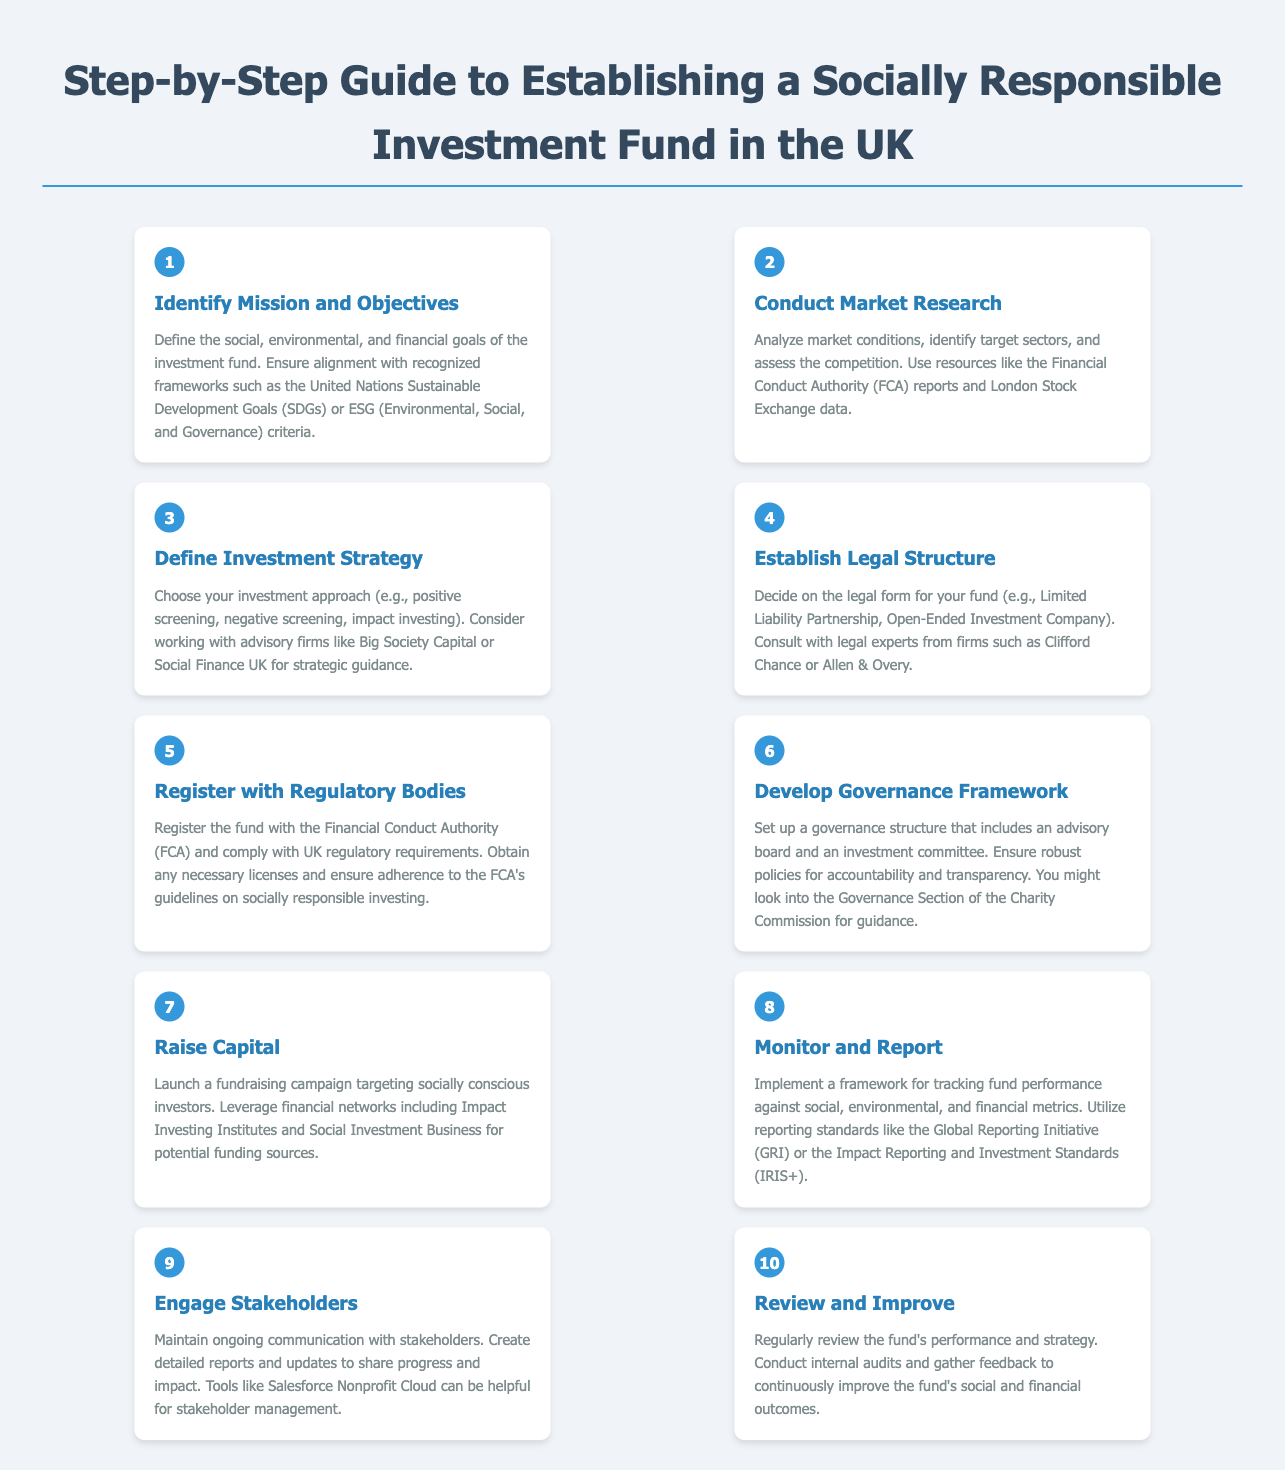What is the first step in establishing a socially responsible investment fund? The first step outlined in the document is to "Identify Mission and Objectives," where one defines the goals of the investment fund.
Answer: Identify Mission and Objectives What legal structure can be used for the fund? The document mentions options such as Limited Liability Partnership and Open-Ended Investment Company for the fund's legal structure.
Answer: Limited Liability Partnership, Open-Ended Investment Company Which body must the fund register with? According to the document, the fund must register with the Financial Conduct Authority to comply with UK regulatory requirements.
Answer: Financial Conduct Authority What is a key consideration when defining the investment strategy? The document suggests choosing an investment approach, such as positive screening or impact investing, as a key consideration in defining the strategy.
Answer: Positive screening, impact investing How many steps are outlined in the guide? The guide consists of a total of 10 steps for establishing a socially responsible investment fund.
Answer: 10 What framework should be implemented for tracking fund performance? The document recommends utilizing standards like the Global Reporting Initiative or Impact Reporting and Investment Standards for tracking performance.
Answer: Global Reporting Initiative, Impact Reporting and Investment Standards What role does stakeholder engagement play in the process? The document emphasizes the importance of maintaining ongoing communication with stakeholders throughout the investment fund's life cycle.
Answer: Ongoing communication Which advisory firms are suggested for strategic guidance? The document mentions Big Society Capital and Social Finance UK as advisory firms for strategic guidance in defining the investment strategy.
Answer: Big Society Capital, Social Finance UK 